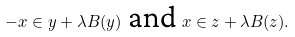Convert formula to latex. <formula><loc_0><loc_0><loc_500><loc_500>- x \in y + \lambda B ( y ) \text { and } x \in z + \lambda B ( z ) .</formula> 